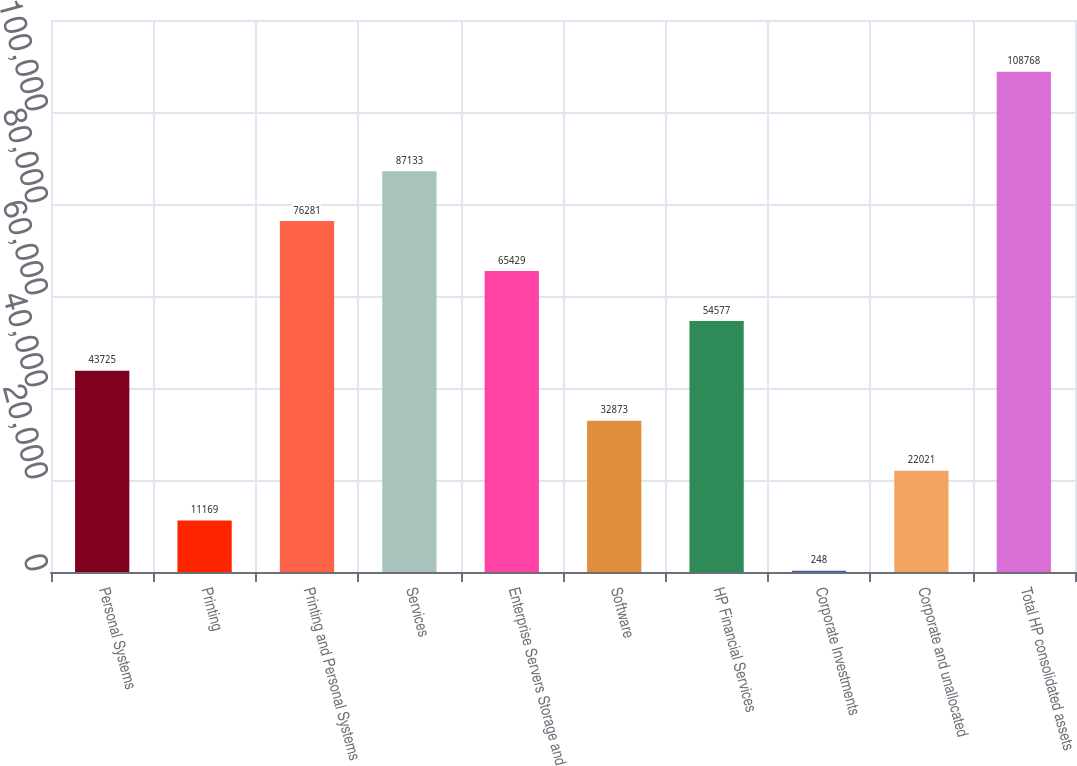Convert chart to OTSL. <chart><loc_0><loc_0><loc_500><loc_500><bar_chart><fcel>Personal Systems<fcel>Printing<fcel>Printing and Personal Systems<fcel>Services<fcel>Enterprise Servers Storage and<fcel>Software<fcel>HP Financial Services<fcel>Corporate Investments<fcel>Corporate and unallocated<fcel>Total HP consolidated assets<nl><fcel>43725<fcel>11169<fcel>76281<fcel>87133<fcel>65429<fcel>32873<fcel>54577<fcel>248<fcel>22021<fcel>108768<nl></chart> 